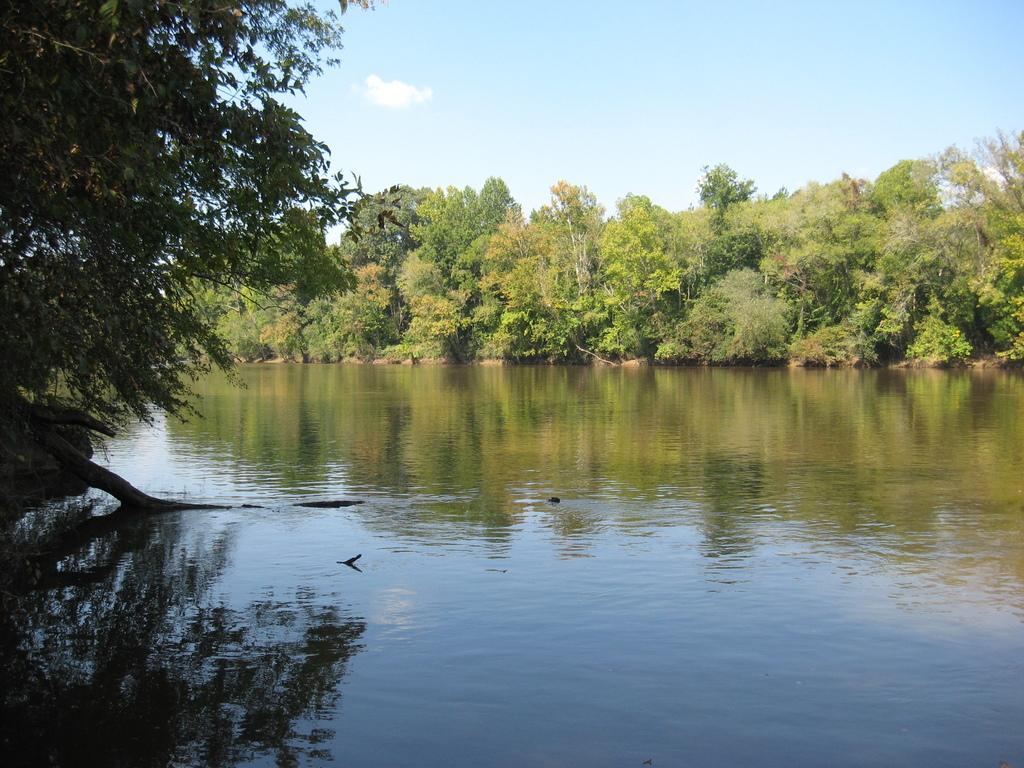What is visible in the image? Water, trees, and the sky are visible in the image. Can you describe the natural environment in the image? The natural environment includes water, trees, and the sky. What type of vegetation is present in the image? Trees are present in the image. What type of system do the giants use to communicate with each other in the image? There are no giants present in the image, so it is not possible to determine what type of system they might use to communicate. 